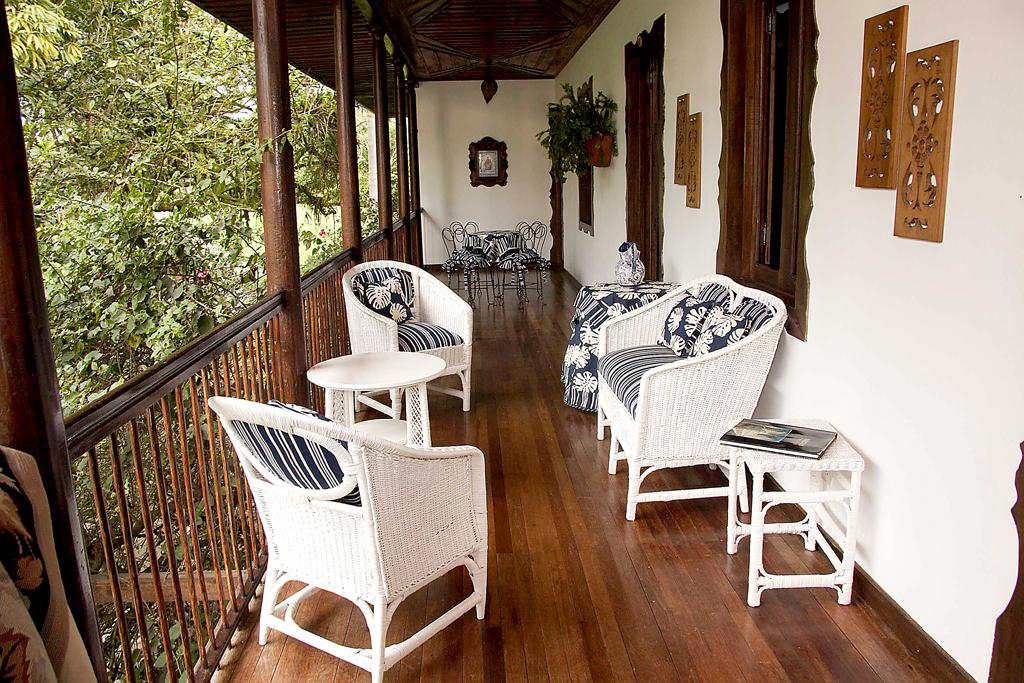What type of outdoor space is visible in the image? There is a balcony in the image. What furniture is present on the balcony? There is a beautiful chair on the balcony. What decorative items can be seen on the wall in the image? There are frames on the wall in the image. What type of natural scenery is visible in the image? Trees are visible in the image. What riddle is the woman trying to solve on the balcony? There is no woman present in the image, and therefore no riddle can be observed. How many trees are visible in the image? The number of trees visible in the image cannot be determined from the provided facts. 